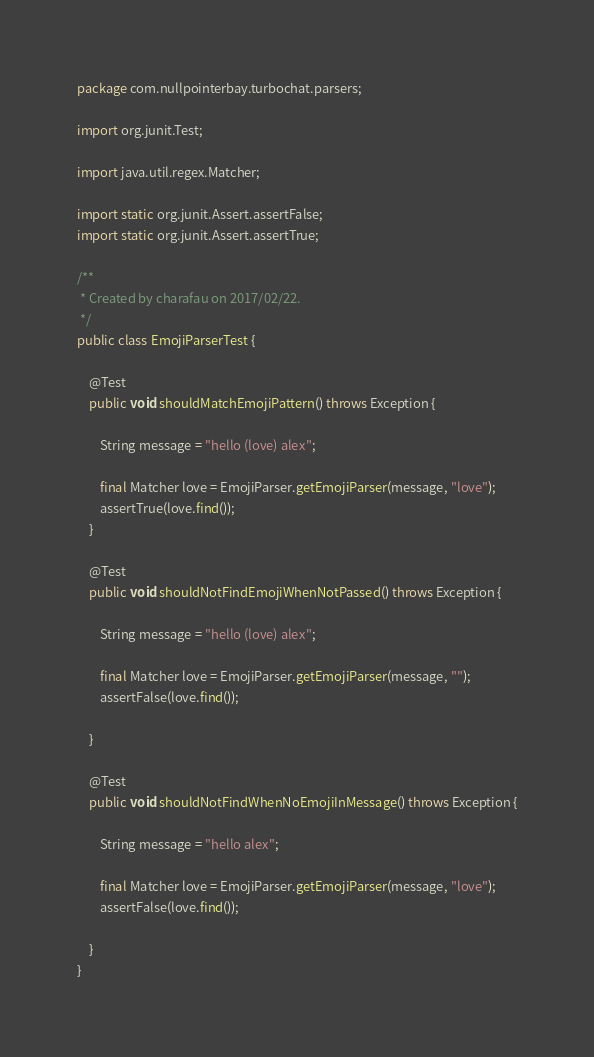<code> <loc_0><loc_0><loc_500><loc_500><_Java_>package com.nullpointerbay.turbochat.parsers;

import org.junit.Test;

import java.util.regex.Matcher;

import static org.junit.Assert.assertFalse;
import static org.junit.Assert.assertTrue;

/**
 * Created by charafau on 2017/02/22.
 */
public class EmojiParserTest {

    @Test
    public void shouldMatchEmojiPattern() throws Exception {

        String message = "hello (love) alex";

        final Matcher love = EmojiParser.getEmojiParser(message, "love");
        assertTrue(love.find());
    }

    @Test
    public void shouldNotFindEmojiWhenNotPassed() throws Exception {

        String message = "hello (love) alex";

        final Matcher love = EmojiParser.getEmojiParser(message, "");
        assertFalse(love.find());

    }

    @Test
    public void shouldNotFindWhenNoEmojiInMessage() throws Exception {

        String message = "hello alex";

        final Matcher love = EmojiParser.getEmojiParser(message, "love");
        assertFalse(love.find());

    }
}</code> 